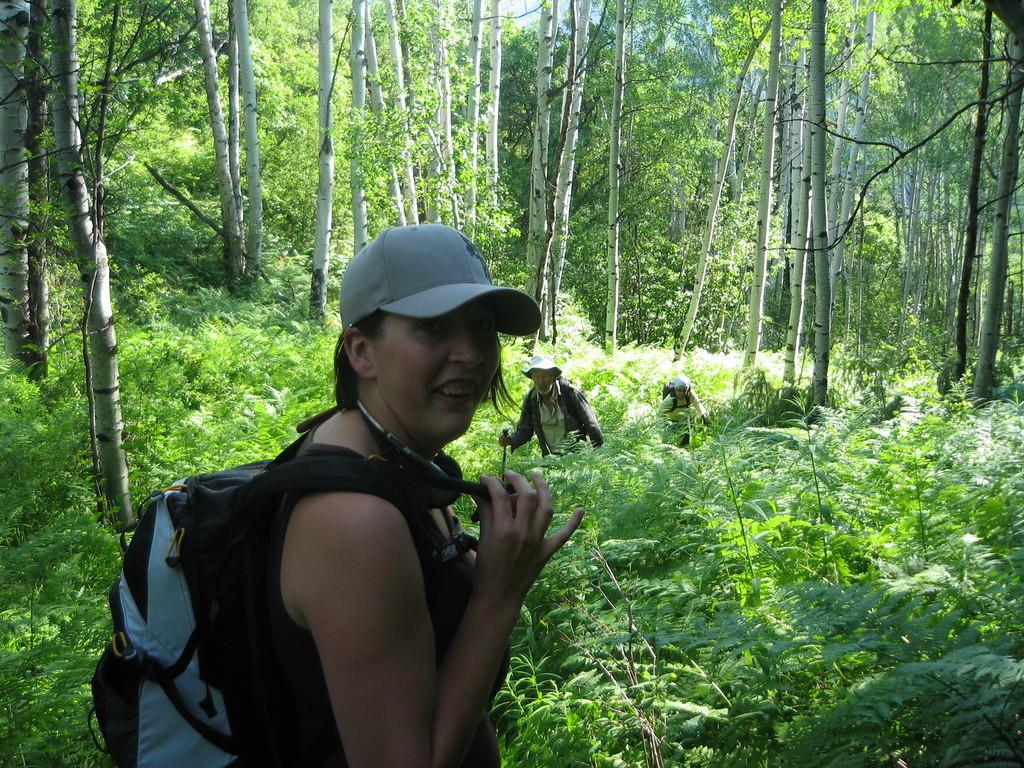Who is present in the image? There is a woman in the image. What is the woman wearing? The woman is wearing a bag. What type of vegetation can be seen in the image? There are plants and trees in the image. How many people are present in the image? There are people in the image, including the woman. What time of day is it in the image, and what are the people writing? There is no indication of the time of day in the image, and no one is shown writing. 